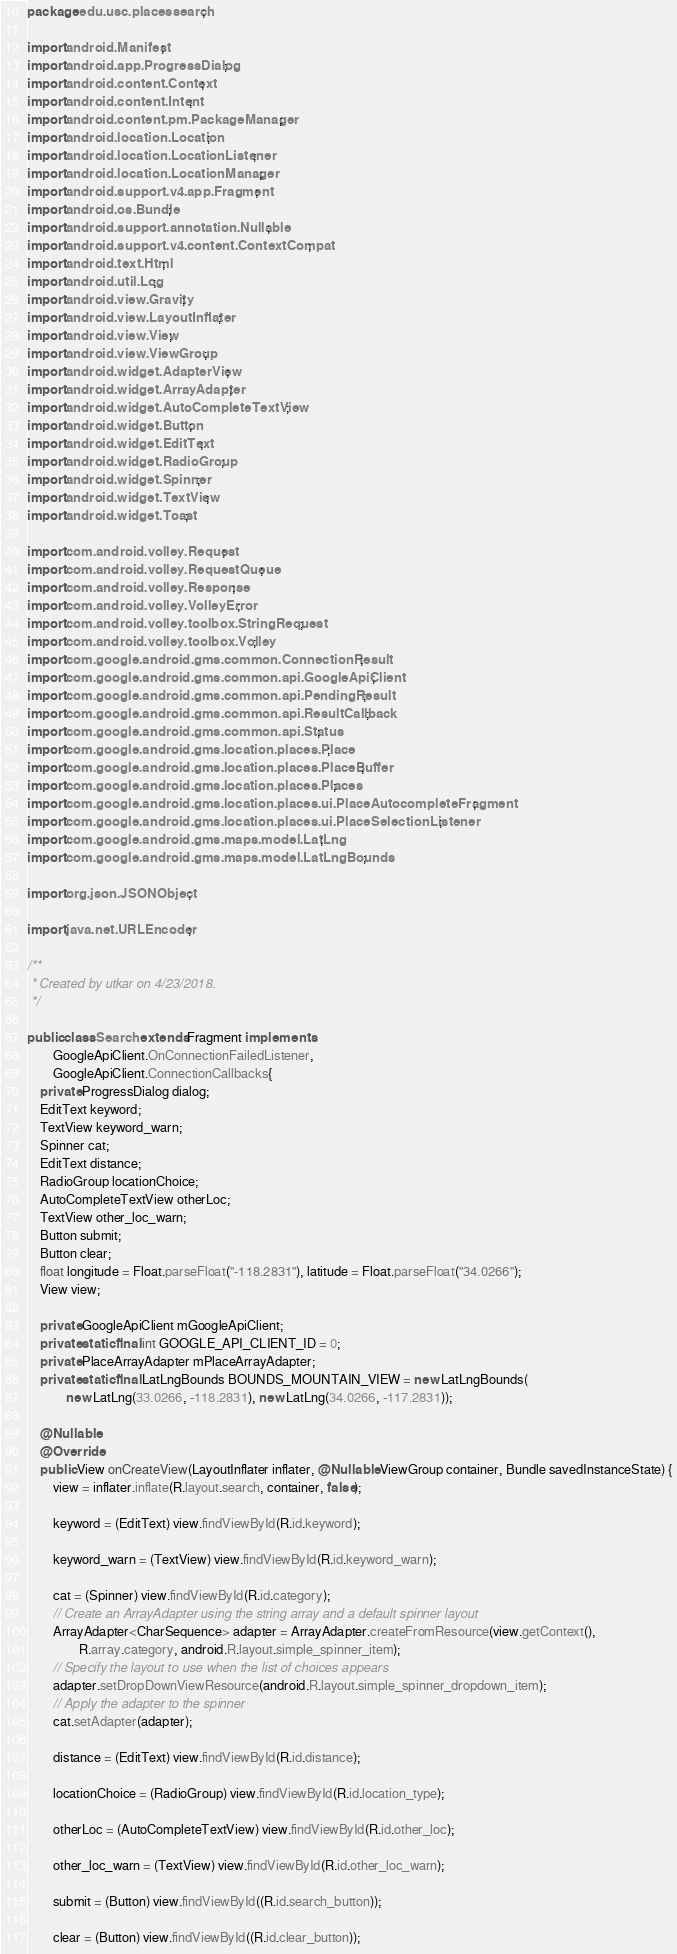Convert code to text. <code><loc_0><loc_0><loc_500><loc_500><_Java_>package edu.usc.placessearch;

import android.Manifest;
import android.app.ProgressDialog;
import android.content.Context;
import android.content.Intent;
import android.content.pm.PackageManager;
import android.location.Location;
import android.location.LocationListener;
import android.location.LocationManager;
import android.support.v4.app.Fragment;
import android.os.Bundle;
import android.support.annotation.Nullable;
import android.support.v4.content.ContextCompat;
import android.text.Html;
import android.util.Log;
import android.view.Gravity;
import android.view.LayoutInflater;
import android.view.View;
import android.view.ViewGroup;
import android.widget.AdapterView;
import android.widget.ArrayAdapter;
import android.widget.AutoCompleteTextView;
import android.widget.Button;
import android.widget.EditText;
import android.widget.RadioGroup;
import android.widget.Spinner;
import android.widget.TextView;
import android.widget.Toast;

import com.android.volley.Request;
import com.android.volley.RequestQueue;
import com.android.volley.Response;
import com.android.volley.VolleyError;
import com.android.volley.toolbox.StringRequest;
import com.android.volley.toolbox.Volley;
import com.google.android.gms.common.ConnectionResult;
import com.google.android.gms.common.api.GoogleApiClient;
import com.google.android.gms.common.api.PendingResult;
import com.google.android.gms.common.api.ResultCallback;
import com.google.android.gms.common.api.Status;
import com.google.android.gms.location.places.Place;
import com.google.android.gms.location.places.PlaceBuffer;
import com.google.android.gms.location.places.Places;
import com.google.android.gms.location.places.ui.PlaceAutocompleteFragment;
import com.google.android.gms.location.places.ui.PlaceSelectionListener;
import com.google.android.gms.maps.model.LatLng;
import com.google.android.gms.maps.model.LatLngBounds;

import org.json.JSONObject;

import java.net.URLEncoder;

/**
 * Created by utkar on 4/23/2018.
 */

public class Search extends Fragment implements
        GoogleApiClient.OnConnectionFailedListener,
        GoogleApiClient.ConnectionCallbacks{
    private ProgressDialog dialog;
    EditText keyword;
    TextView keyword_warn;
    Spinner cat;
    EditText distance;
    RadioGroup locationChoice;
    AutoCompleteTextView otherLoc;
    TextView other_loc_warn;
    Button submit;
    Button clear;
    float longitude = Float.parseFloat("-118.2831"), latitude = Float.parseFloat("34.0266");
    View view;

    private GoogleApiClient mGoogleApiClient;
    private static final int GOOGLE_API_CLIENT_ID = 0;
    private PlaceArrayAdapter mPlaceArrayAdapter;
    private static final LatLngBounds BOUNDS_MOUNTAIN_VIEW = new LatLngBounds(
            new LatLng(33.0266, -118.2831), new LatLng(34.0266, -117.2831));

    @Nullable
    @Override
    public View onCreateView(LayoutInflater inflater, @Nullable ViewGroup container, Bundle savedInstanceState) {
        view = inflater.inflate(R.layout.search, container, false);

        keyword = (EditText) view.findViewById(R.id.keyword);

        keyword_warn = (TextView) view.findViewById(R.id.keyword_warn);

        cat = (Spinner) view.findViewById(R.id.category);
        // Create an ArrayAdapter using the string array and a default spinner layout
        ArrayAdapter<CharSequence> adapter = ArrayAdapter.createFromResource(view.getContext(),
                R.array.category, android.R.layout.simple_spinner_item);
        // Specify the layout to use when the list of choices appears
        adapter.setDropDownViewResource(android.R.layout.simple_spinner_dropdown_item);
        // Apply the adapter to the spinner
        cat.setAdapter(adapter);

        distance = (EditText) view.findViewById(R.id.distance);

        locationChoice = (RadioGroup) view.findViewById(R.id.location_type);

        otherLoc = (AutoCompleteTextView) view.findViewById(R.id.other_loc);

        other_loc_warn = (TextView) view.findViewById(R.id.other_loc_warn);

        submit = (Button) view.findViewById((R.id.search_button));

        clear = (Button) view.findViewById((R.id.clear_button));
</code> 